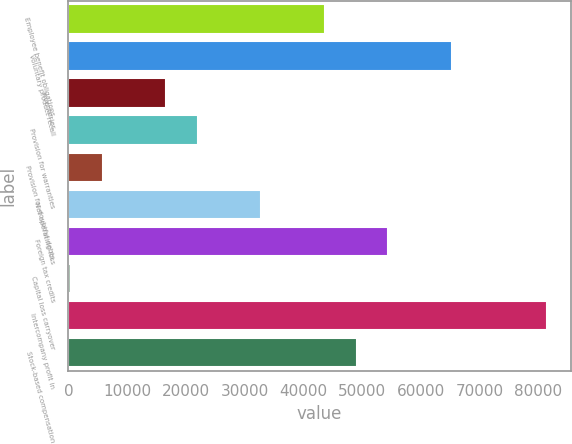Convert chart to OTSL. <chart><loc_0><loc_0><loc_500><loc_500><bar_chart><fcel>Employee benefit obligations<fcel>Voluntary product recall<fcel>Inventories<fcel>Provision for warranties<fcel>Provision for doubtful debts<fcel>Net operating loss<fcel>Foreign tax credits<fcel>Capital loss carryover<fcel>Intercompany profit in<fcel>Stock-based compensation<nl><fcel>43652.4<fcel>65233.6<fcel>16675.9<fcel>22071.2<fcel>5885.3<fcel>32861.8<fcel>54443<fcel>490<fcel>81419.5<fcel>49047.7<nl></chart> 